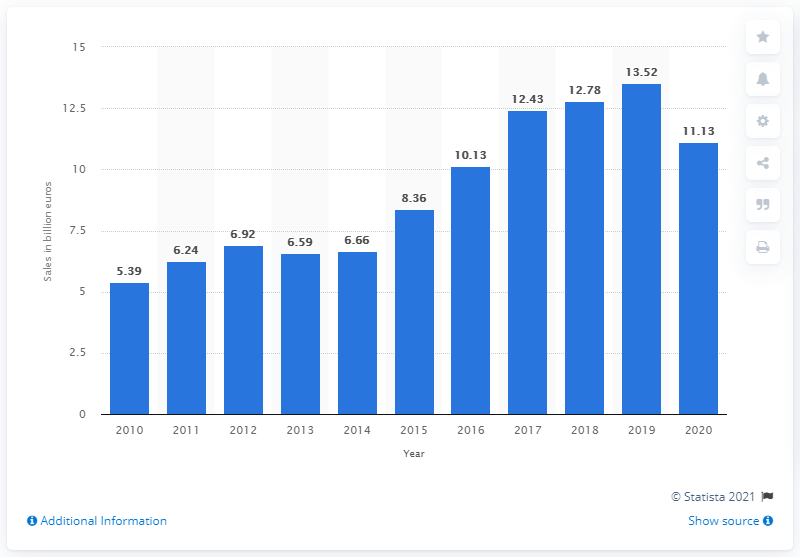Outline some significant characteristics in this image. In 2020, the net sales of footwear for the Adidas Group was 11.13 billion US dollars. 